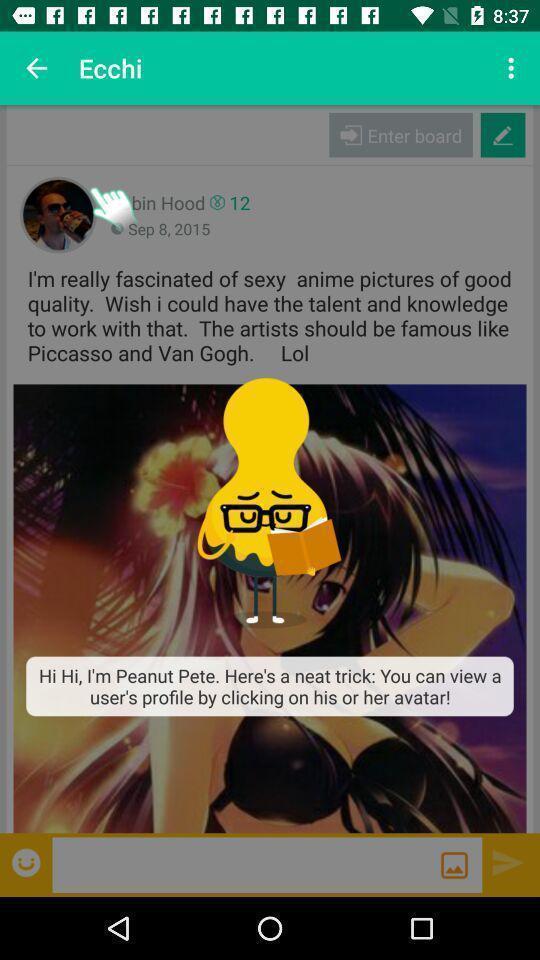What details can you identify in this image? Pop-up of instruction to how to view user profile. 